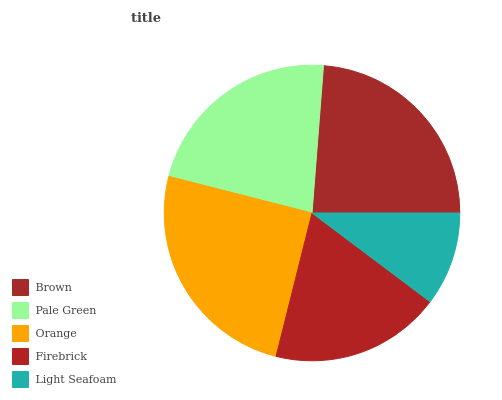Is Light Seafoam the minimum?
Answer yes or no. Yes. Is Orange the maximum?
Answer yes or no. Yes. Is Pale Green the minimum?
Answer yes or no. No. Is Pale Green the maximum?
Answer yes or no. No. Is Brown greater than Pale Green?
Answer yes or no. Yes. Is Pale Green less than Brown?
Answer yes or no. Yes. Is Pale Green greater than Brown?
Answer yes or no. No. Is Brown less than Pale Green?
Answer yes or no. No. Is Pale Green the high median?
Answer yes or no. Yes. Is Pale Green the low median?
Answer yes or no. Yes. Is Orange the high median?
Answer yes or no. No. Is Brown the low median?
Answer yes or no. No. 